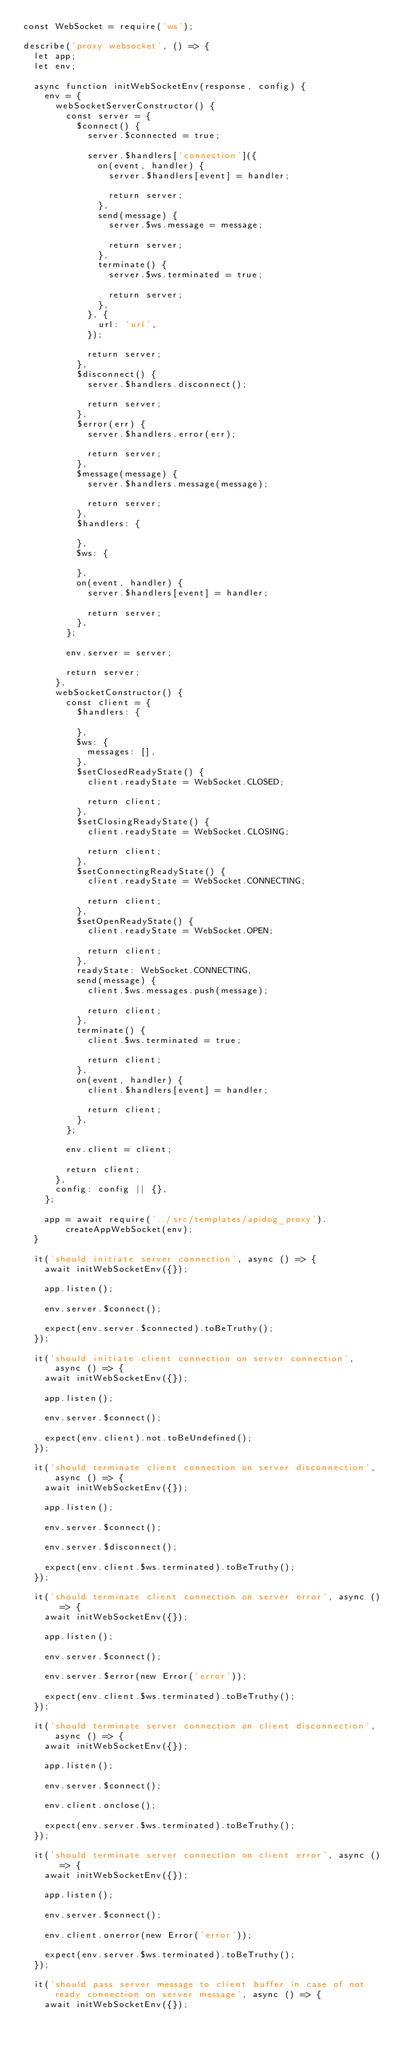Convert code to text. <code><loc_0><loc_0><loc_500><loc_500><_JavaScript_>const WebSocket = require('ws');

describe('proxy websocket', () => {
  let app;
  let env;

  async function initWebSocketEnv(response, config) {
    env = {
      webSocketServerConstructor() {
        const server = {
          $connect() {
            server.$connected = true;

            server.$handlers['connection']({
              on(event, handler) {
                server.$handlers[event] = handler;

                return server;
              },
              send(message) {
                server.$ws.message = message;

                return server;
              },
              terminate() {
                server.$ws.terminated = true;

                return server;
              },
            }, {
              url: 'url',
            });

            return server;
          },
          $disconnect() {
            server.$handlers.disconnect();

            return server;
          },
          $error(err) {
            server.$handlers.error(err);

            return server;
          },
          $message(message) {
            server.$handlers.message(message);

            return server;
          },
          $handlers: {

          },
          $ws: {

          },
          on(event, handler) {
            server.$handlers[event] = handler;

            return server;
          },
        };

        env.server = server;

        return server;
      },
      webSocketConstructor() {
        const client = {
          $handlers: {

          },
          $ws: {
            messages: [],
          },
          $setClosedReadyState() {
            client.readyState = WebSocket.CLOSED;

            return client;
          },
          $setClosingReadyState() {
            client.readyState = WebSocket.CLOSING;

            return client;
          },
          $setConnectingReadyState() {
            client.readyState = WebSocket.CONNECTING;

            return client;
          },
          $setOpenReadyState() {
            client.readyState = WebSocket.OPEN;

            return client;
          },
          readyState: WebSocket.CONNECTING,
          send(message) {
            client.$ws.messages.push(message);

            return client;
          },
          terminate() {
            client.$ws.terminated = true;

            return client;
          },
          on(event, handler) {
            client.$handlers[event] = handler;

            return client;
          },
        };

        env.client = client;

        return client;
      },
      config: config || {},
    };

    app = await require('../src/templates/apidog_proxy').createAppWebSocket(env);
  }

  it('should initiate server connection', async () => {
    await initWebSocketEnv({});

    app.listen();

    env.server.$connect();

    expect(env.server.$connected).toBeTruthy();
  });

  it('should initiate client connection on server connection', async () => {
    await initWebSocketEnv({});

    app.listen();

    env.server.$connect();

    expect(env.client).not.toBeUndefined();
  });

  it('should terminate client connection on server disconnection', async () => {
    await initWebSocketEnv({});

    app.listen();

    env.server.$connect();

    env.server.$disconnect();

    expect(env.client.$ws.terminated).toBeTruthy();
  });

  it('should terminate client connection on server error', async () => {
    await initWebSocketEnv({});

    app.listen();

    env.server.$connect();

    env.server.$error(new Error('error'));

    expect(env.client.$ws.terminated).toBeTruthy();
  });

  it('should terminate server connection on client disconnection', async () => {
    await initWebSocketEnv({});

    app.listen();

    env.server.$connect();

    env.client.onclose();

    expect(env.server.$ws.terminated).toBeTruthy();
  });

  it('should terminate server connection on client error', async () => {
    await initWebSocketEnv({});

    app.listen();

    env.server.$connect();

    env.client.onerror(new Error('error'));

    expect(env.server.$ws.terminated).toBeTruthy();
  });

  it('should pass server message to client buffer in case of not ready connection on server message', async () => {
    await initWebSocketEnv({});
</code> 